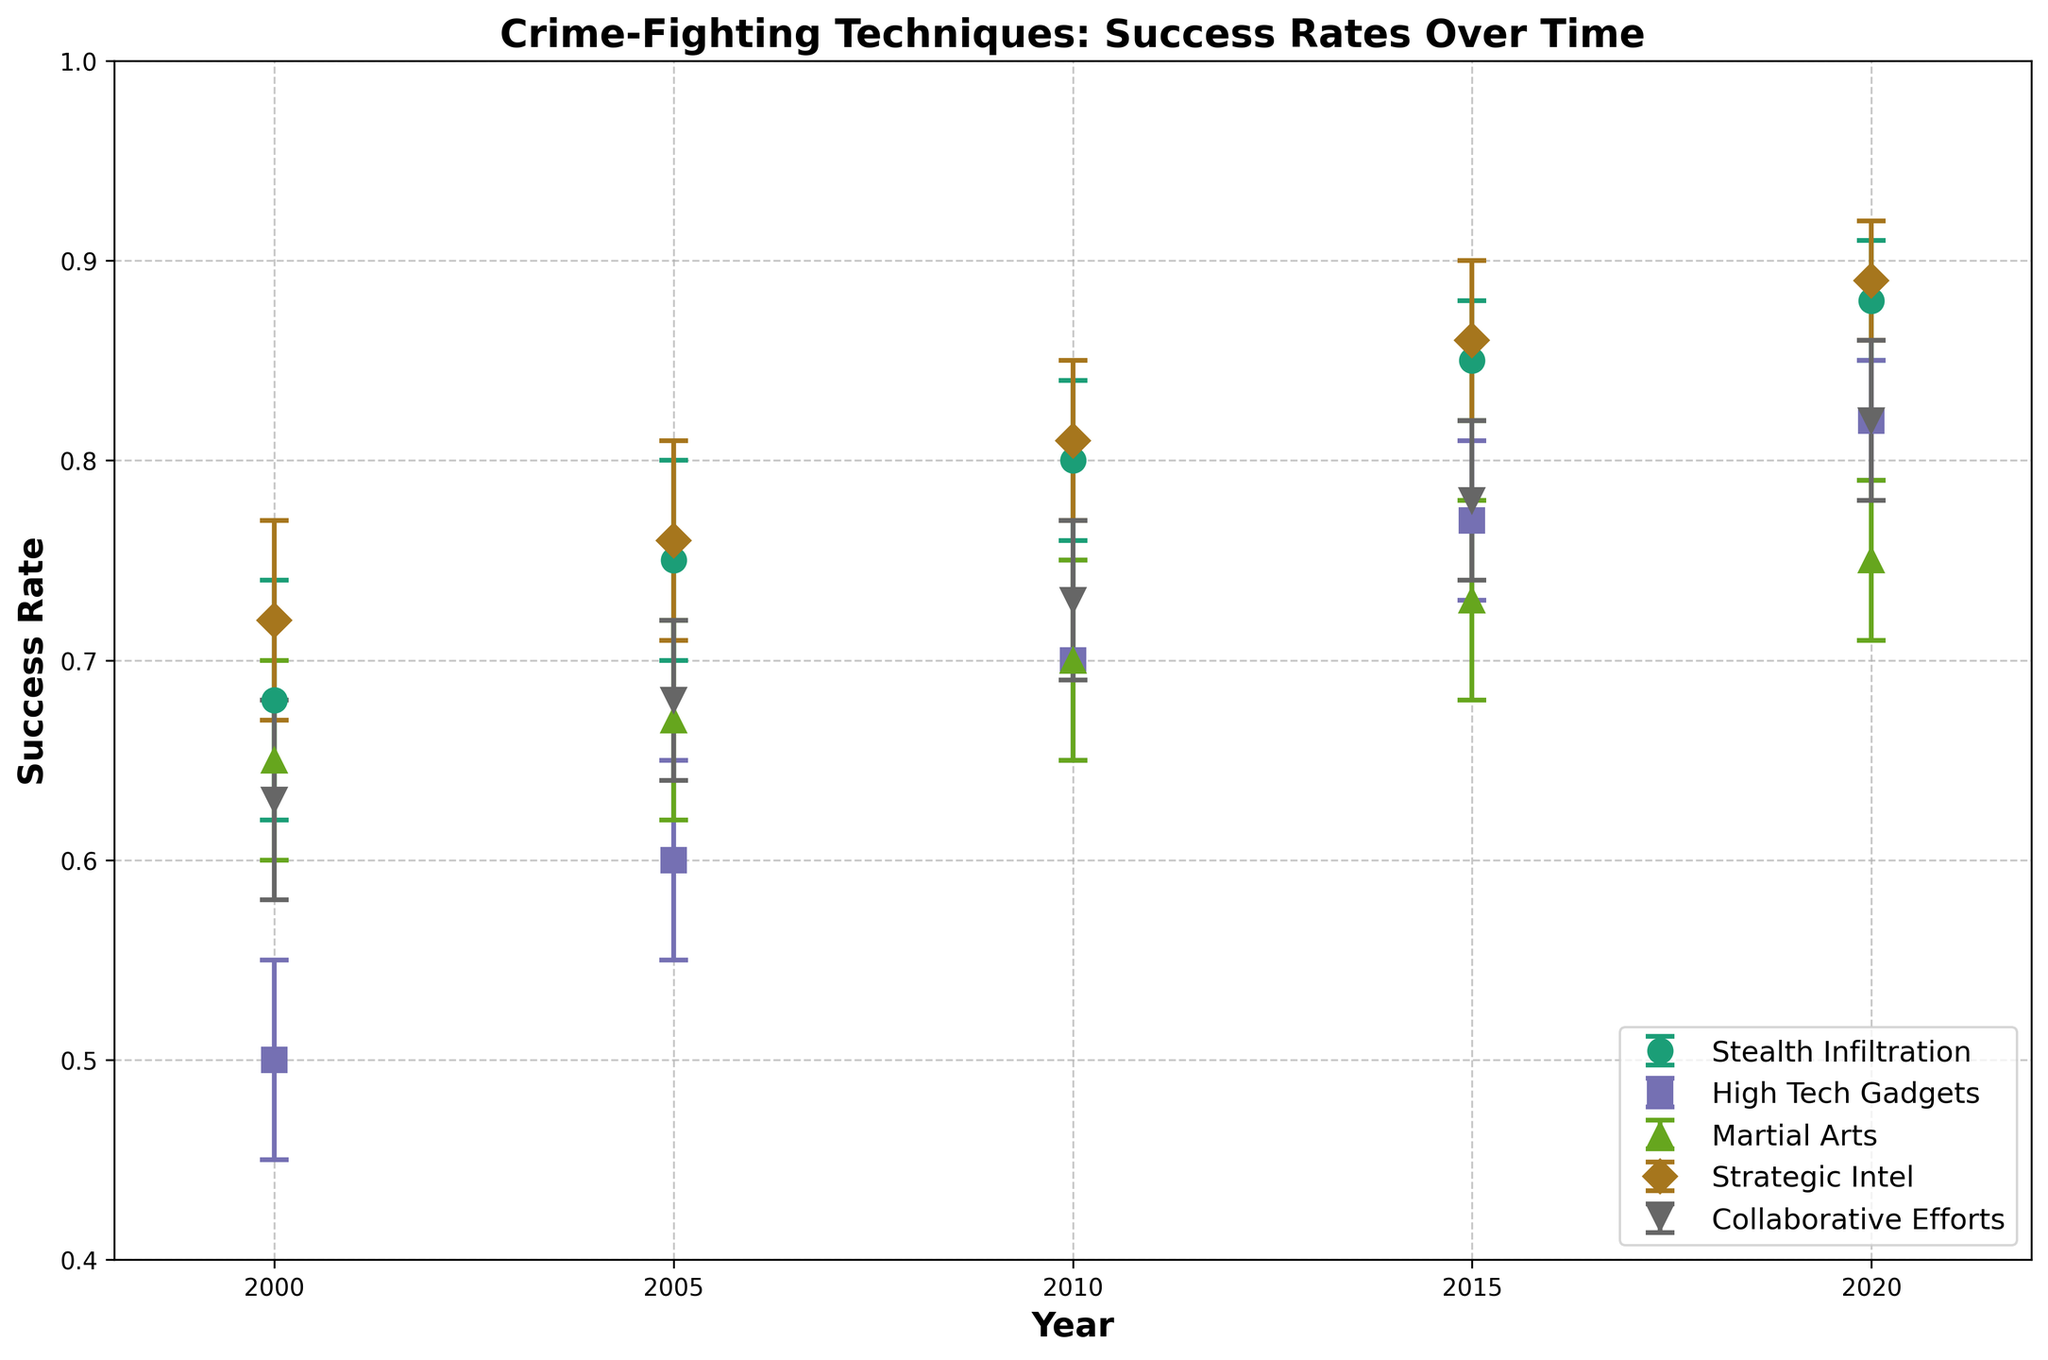How many techniques are plotted in the figure? By counting the number of different labels in the legend, we can determine the number of techniques. The techniques listed are Stealth Infiltration, High Tech Gadgets, Martial Arts, Strategic Intel, and Collaborative Efforts.
Answer: 5 What is the title of the figure? The title of the figure is usually found at the top and centers over the plot area in bold text.
Answer: Crime-Fighting Techniques: Success Rates Over Time Which technique has the highest success rate in 2020? Look at the data points for the year 2020 and compare their success rates. The technique with the highest value is the one of interest.
Answer: Strategic Intel What's the difference in success rate between Stealth Infiltration and High Tech Gadgets in the year 2000? Find the success rates of Stealth Infiltration and High Tech Gadgets for the year 2000 and subtract them: 0.68 - 0.50.
Answer: 0.18 What is the average success rate of Martial Arts over the years presented? Add the success rates of Martial Arts for each year and divide by the number of years: (0.65 + 0.67 + 0.70 + 0.73 + 0.75) / 5.
Answer: 0.7 Which technique shows the most improvement in success rate from 2000 to 2020? Calculate the difference between the 2020 and 2000 success rates for each technique. The technique with the largest difference shows the most improvement.
Answer: High Tech Gadgets Which techniques have a success rate above 0.8 in 2020? Look at the success rates for the year 2020 and identify values greater than 0.8. The corresponding techniques are the ones of interest.
Answer: Stealth Infiltration, Strategic Intel, Collaborative Efforts What is the confidence interval range for Strategic Intel in 2010? Identify the confidence interval values for Strategic Intel in 2010 and find the range by subtracting the low value from the high value: 0.85 - 0.77.
Answer: 0.08 How does the success rate of Collaborative Efforts change from 2010 to 2015? Compare the success rates for Collaborative Efforts in 2010 and 2015 by subtracting the 2010 value from the 2015 value: 0.78 - 0.73.
Answer: 0.05 Which year shows the smallest difference in success rates between Stealth Infiltration and Martial Arts? Calculate the difference in success rates between Stealth Infiltration and Martial Arts for each year and identify the year with the smallest difference.
Answer: 2020 